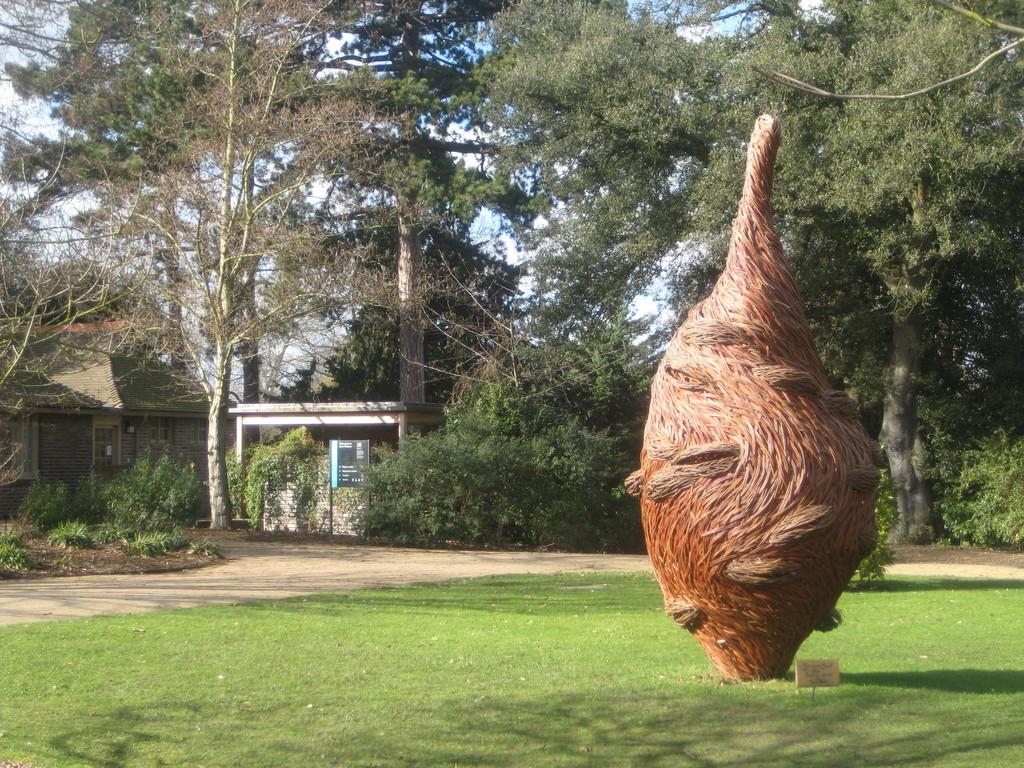What type of vegetation can be seen in the image? There is grass, trees, and plants in the image. What kind of artwork is present in the image? There is a sculpture in the image. What might be used for providing directions in the image? Name boards are present in the image. What type of surface is visible in the image? There is a path in the image. What type of structure is visible in the image? There is a house in the image. What is visible in the background of the image? The sky is visible in the background of the image. What type of tooth is visible in the image? There is no tooth present in the image. What type of meat is being prepared on the path in the image? There is no meat or preparation of meat visible in the image. 